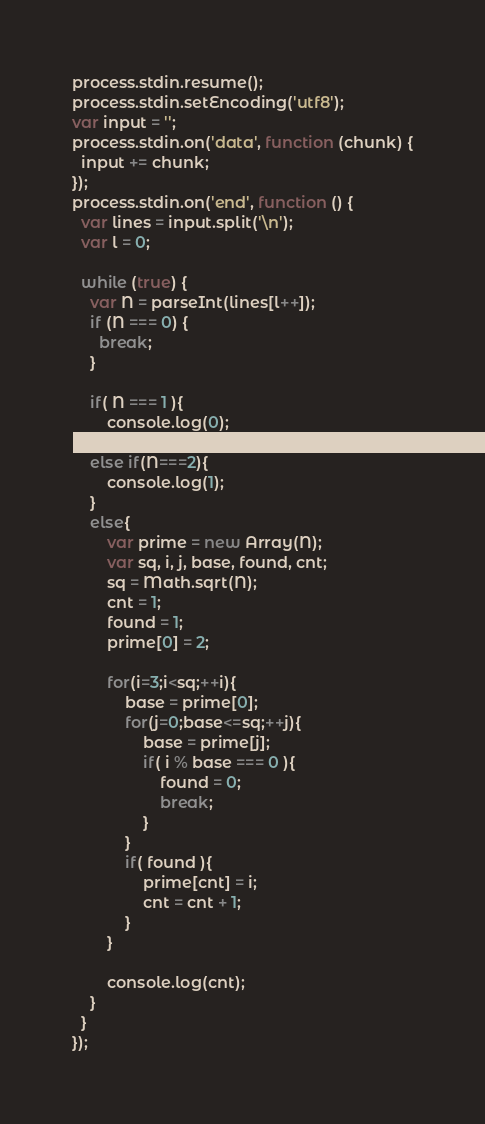<code> <loc_0><loc_0><loc_500><loc_500><_JavaScript_>process.stdin.resume();
process.stdin.setEncoding('utf8');
var input = '';
process.stdin.on('data', function (chunk) {
  input += chunk;
});
process.stdin.on('end', function () {
  var lines = input.split('\n');
  var l = 0;

  while (true) {
    var N = parseInt(lines[l++]);
    if (N === 0) {
      break;
    }
    
    if( N === 1 ){
        console.log(0);
    }
    else if(N===2){
        console.log(1);
    }
    else{
        var prime = new Array(N);
        var sq, i, j, base, found, cnt;
        sq = Math.sqrt(N);
        cnt = 1;
        found = 1;
        prime[0] = 2;
            
        for(i=3;i<sq;++i){
            base = prime[0];
            for(j=0;base<=sq;++j){
                base = prime[j];
                if( i % base === 0 ){
                    found = 0;
                    break;
                }
            }
            if( found ){
                prime[cnt] = i;
                cnt = cnt + 1;
            }
        }
        
        console.log(cnt);
    }
  }
});</code> 